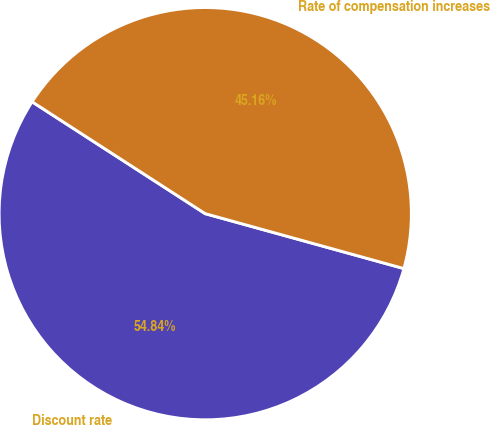<chart> <loc_0><loc_0><loc_500><loc_500><pie_chart><fcel>Discount rate<fcel>Rate of compensation increases<nl><fcel>54.84%<fcel>45.16%<nl></chart> 